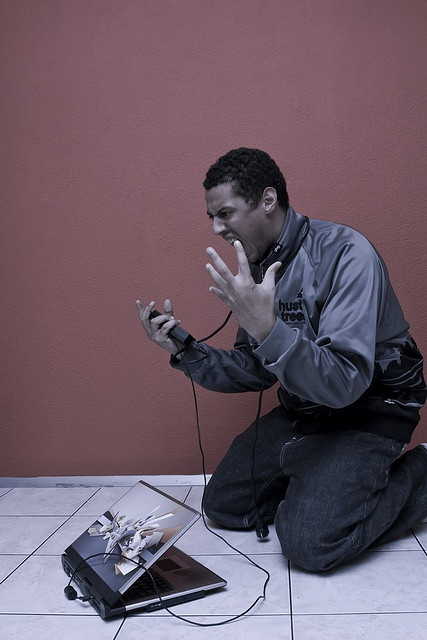Describe the objects in this image and their specific colors. I can see people in brown, black, and gray tones and laptop in brown, black, darkgray, and gray tones in this image. 